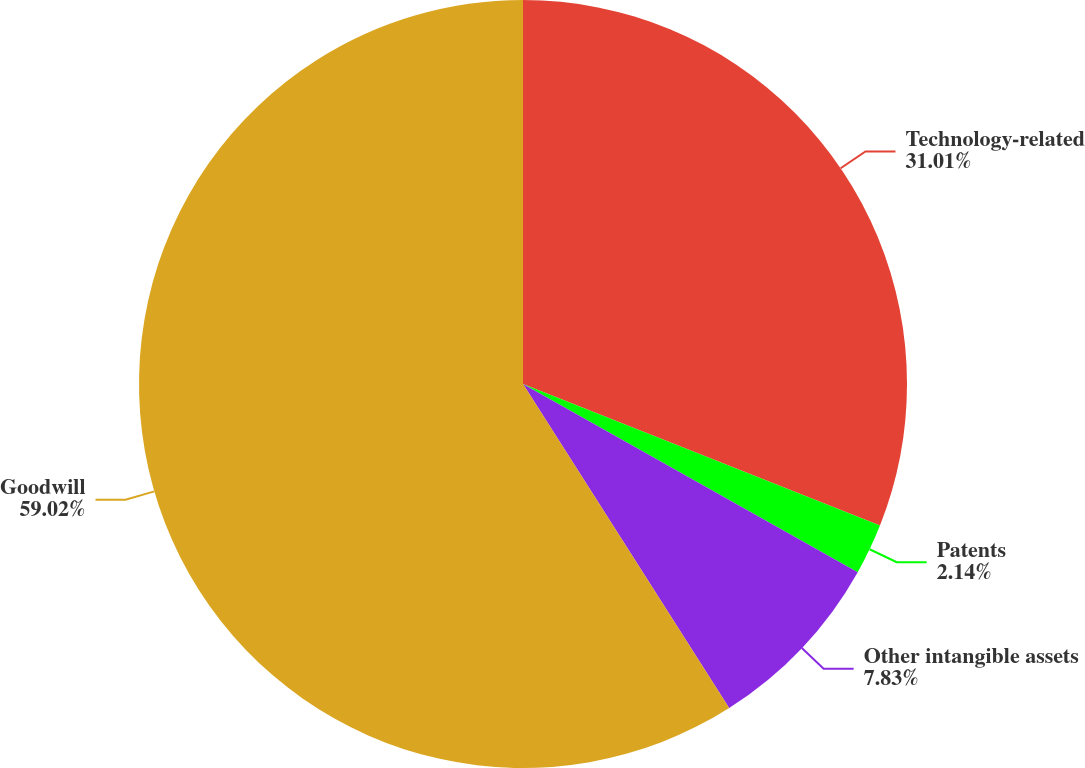Convert chart to OTSL. <chart><loc_0><loc_0><loc_500><loc_500><pie_chart><fcel>Technology-related<fcel>Patents<fcel>Other intangible assets<fcel>Goodwill<nl><fcel>31.01%<fcel>2.14%<fcel>7.83%<fcel>59.02%<nl></chart> 